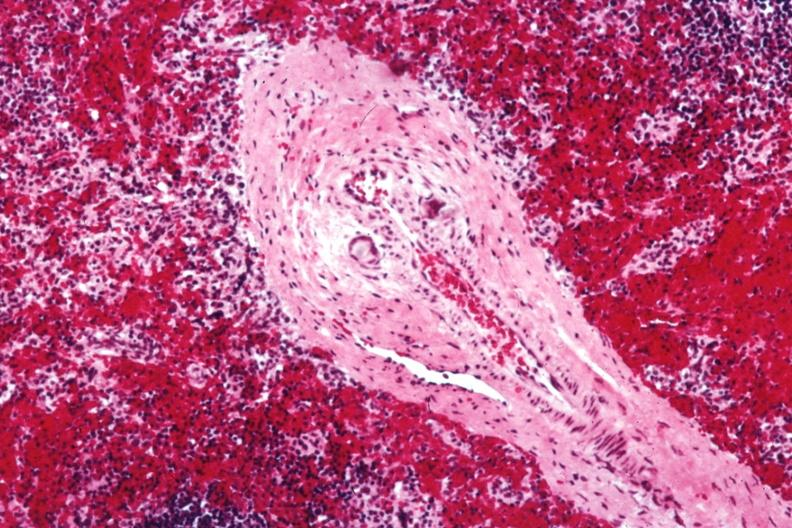s thyroid present?
Answer the question using a single word or phrase. No 